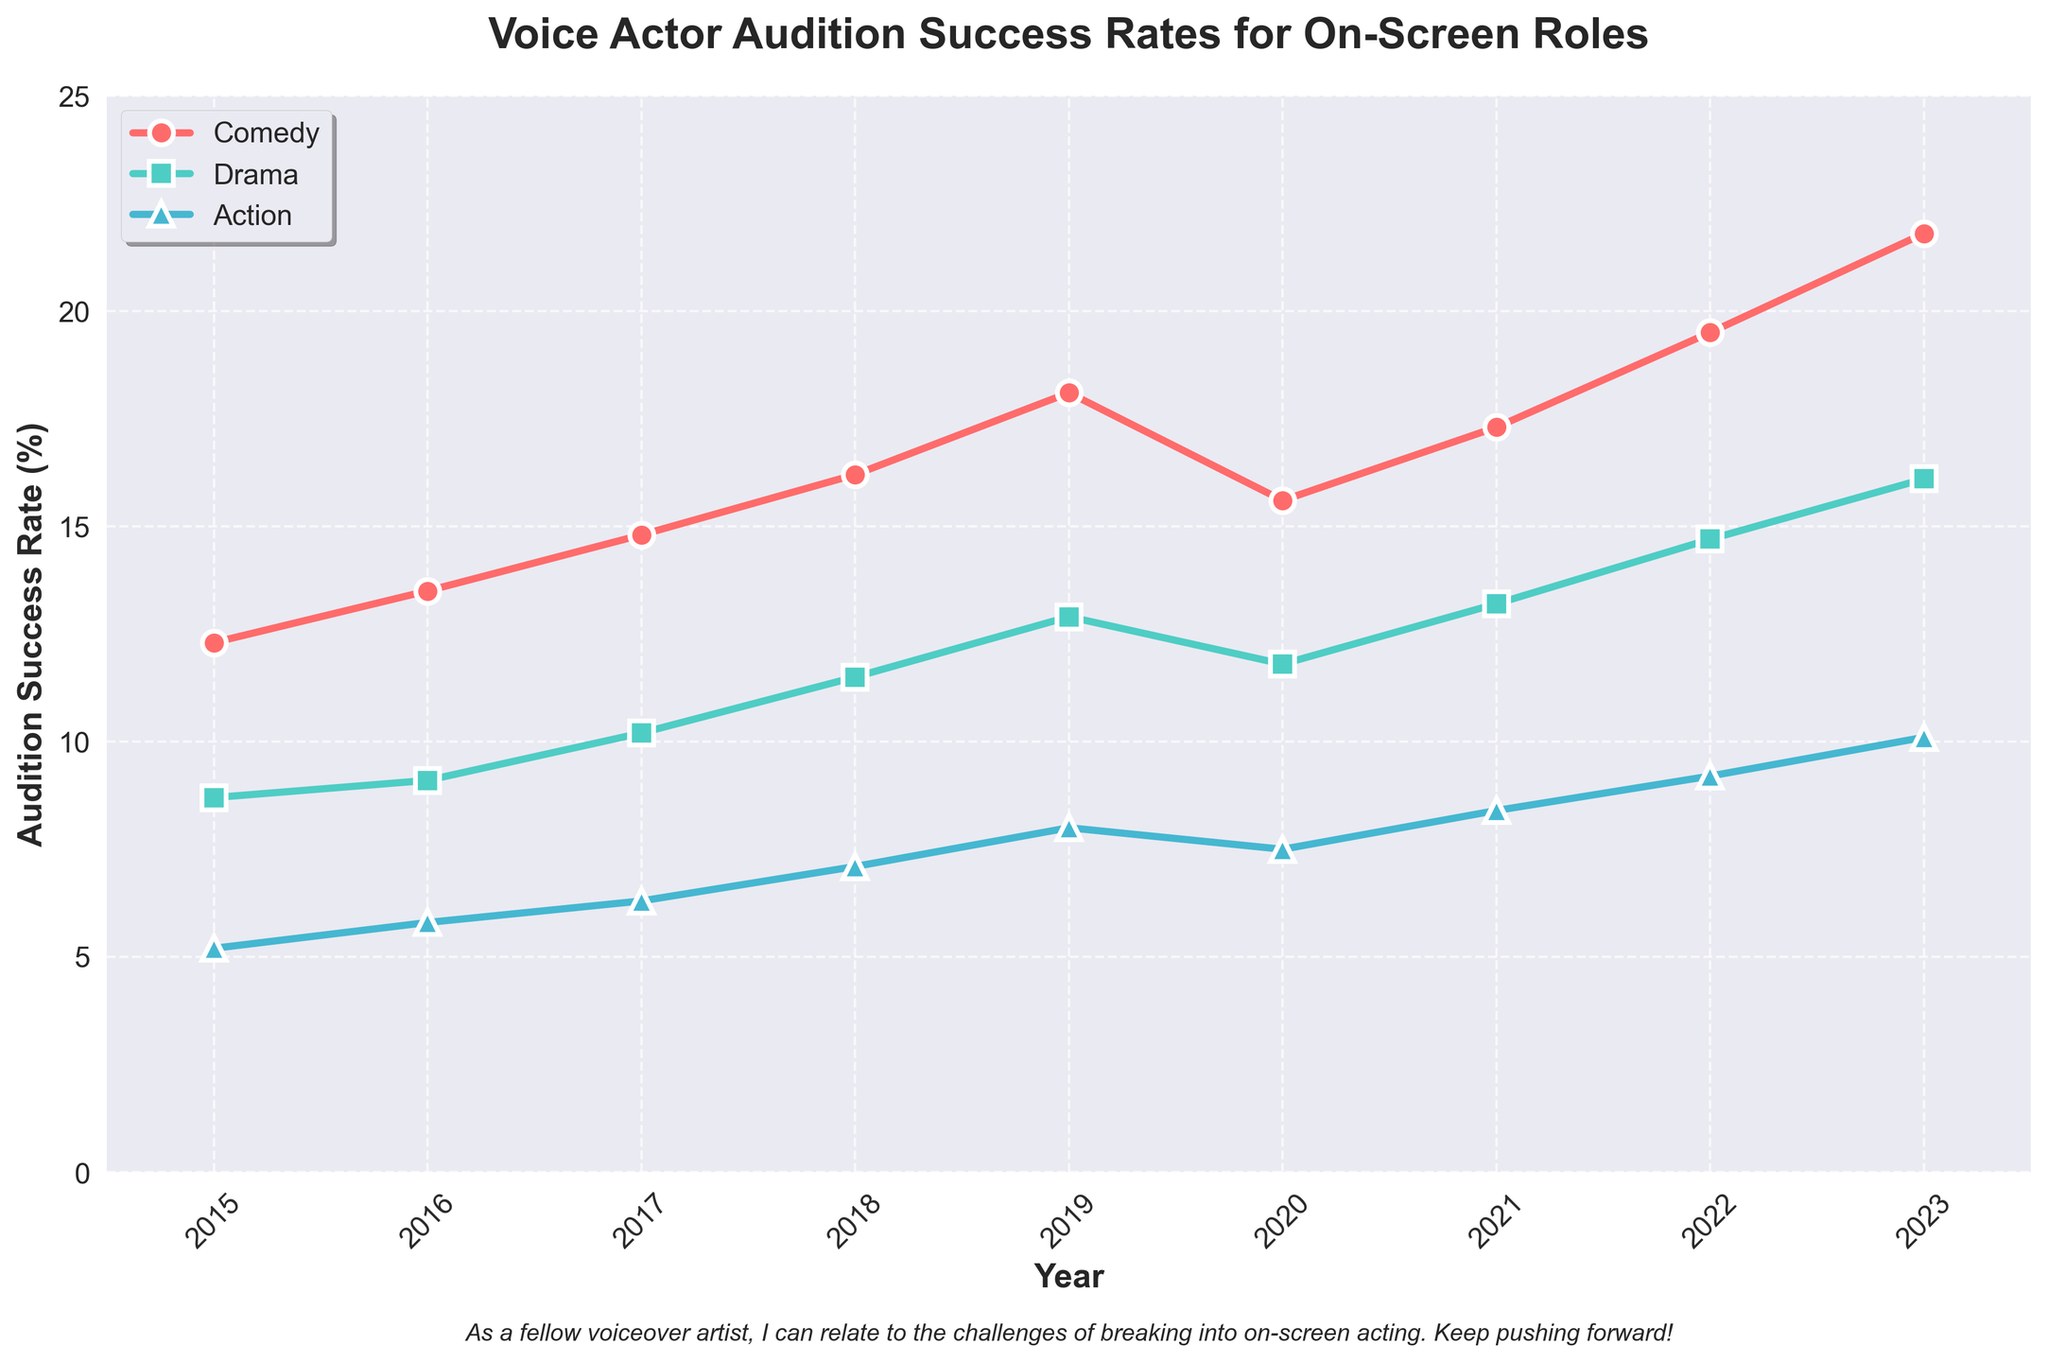What is the overall trend in the success rate for Comedy auditions from 2015 to 2023? The success rate for Comedy auditions shows a general upward trend from 12.3% in 2015 to 21.8% in 2023.
Answer: Upward trend Compare the success rates for Drama and Action genres in 2020. Which genre had a higher success rate? In 2020, the success rate for Drama was 11.8%, while for Action, it was 7.5%. Therefore, Drama had a higher success rate than Action that year.
Answer: Drama Did the success rate for any genre ever decrease from one year to the next? If so, which one(s)? Only the Comedy genre saw a decrease, specifically from 2019 (18.1%) to 2020 (15.6%).
Answer: Comedy By how much did the success rate for Action increase from 2015 to 2023? The success rate for Action increased from 5.2% in 2015 to 10.1% in 2023. Therefore, the increase was 10.1% - 5.2% = 4.9%.
Answer: 4.9% Which year had the highest overall audition success rate for the Comedy genre? The year 2023 had the highest success rate for the Comedy genre, at 21.8%.
Answer: 2023 Calculate the average success rate for Drama auditions from 2015 to 2023. Adding the success rates for Drama from 2015 to 2023 (8.7 + 9.1 + 10.2 + 11.5 + 12.9 + 11.8 + 13.2 + 14.7 + 16.1) gives a total of 108.2. Dividing by the number of years (9) results in an average of 108.2 / 9 ≈ 12.02%.
Answer: ≈ 12.02% Between which consecutive years did the success rate for Action auditions show the highest increase? The increase between consecutive years is as follows: (5.8-5.2) = 0.6 (2015-2016), (6.3-5.8) = 0.5 (2016-2017), (7.1-6.3) = 0.8 (2017-2018), (8.0-7.1) = 0.9 (2018-2019), (7.5-8.0) = -0.5 (2019-2020), (8.4-7.5) = 0.9 (2020-2021), (9.2-8.4) = 0.8 (2021-2022), (10.1-9.2) = 0.9 (2022-2023). Therefore, the highest increase is 0.9, seen in years 2018-2019, 2020-2021, and 2022-2023.
Answer: 2018-2019, 2020-2021, and 2022-2023 How did the success rate for Drama auditions in 2021 compare to Comedy auditions in the same year? In 2021, the success rate for Drama was 13.2%, whereas for Comedy it was 17.3%. Comedy had a higher success rate than Drama in 2021.
Answer: Comedy What was the success rate difference between Comedy and Action genres in 2019? In 2019, the success rate for Comedy was 18.1%, and for Action, it was 8.0%. The difference is 18.1% - 8.0% = 10.1%.
Answer: 10.1% 